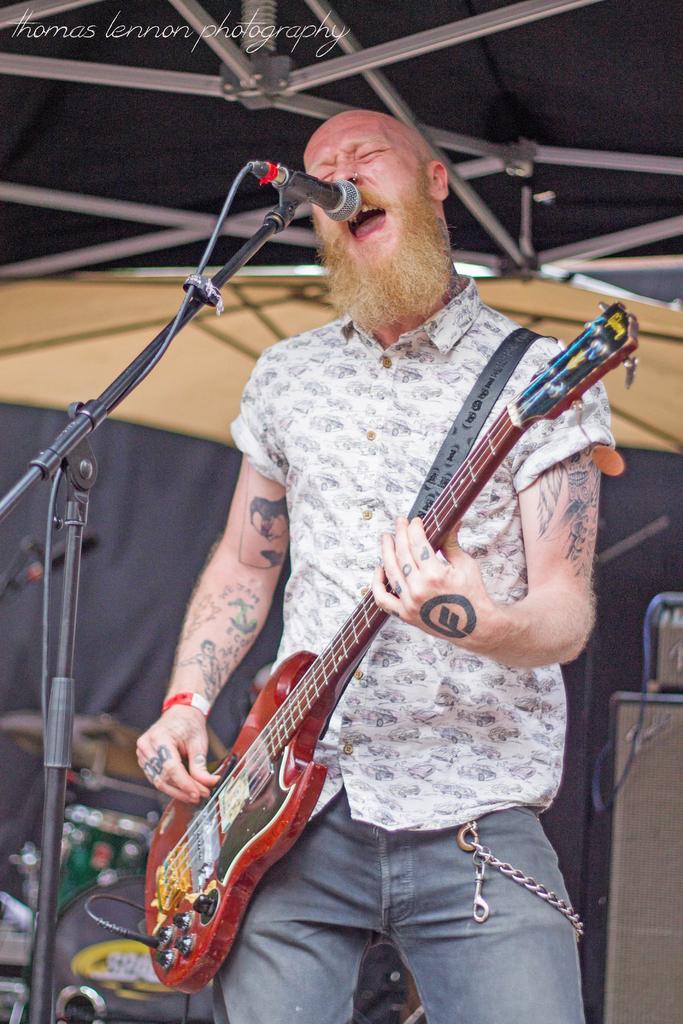Describe this image in one or two sentences. This picture shows a man singing in front of a mic and a stand holding a guitar in his hands. In the background there is a cloth and some musical instruments here. 